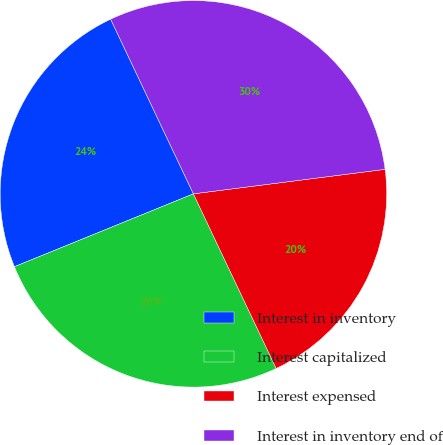Convert chart. <chart><loc_0><loc_0><loc_500><loc_500><pie_chart><fcel>Interest in inventory<fcel>Interest capitalized<fcel>Interest expensed<fcel>Interest in inventory end of<nl><fcel>24.11%<fcel>25.89%<fcel>19.98%<fcel>30.02%<nl></chart> 